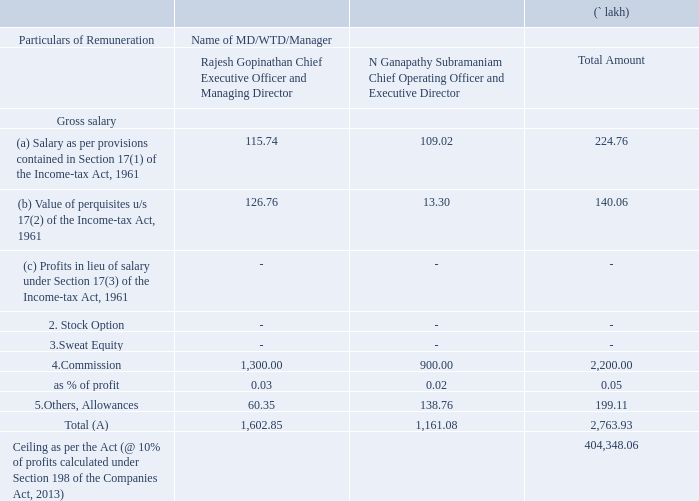VI. REMUNERATION OF DIRECTORS AND KEY MANAGERIAL PERSONNEL
A. Remuneration to Managing Director, Whole-time Directors and / or Manager:
What is the value of stock option granted to the Chief Executive Officer and Managing Director? 0. What is the value of sweat equity remuneration granted to the Chief Operating Officer and Executive Director? 0. Between the CEO and COO, whose commision is higher? Chief executive officer. What is the total gross salary of the CEO and MD? 115.74+126.76
Answer: 242.5. What is the ratio of commision to total gross salary of the COO? 900/(109.02+13.30)
Answer: 7.36. What is difference between the value of Others, Allowances of the CEO and COO? 138.76-60.35 
Answer: 78.41. 